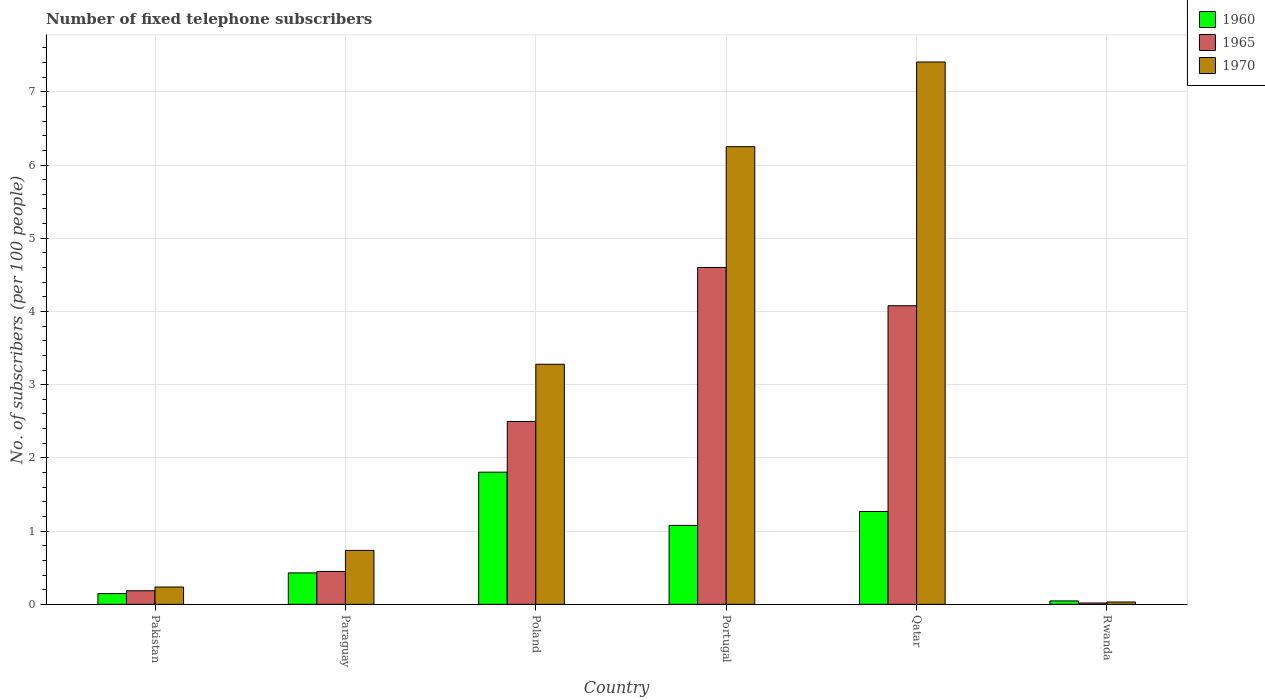Are the number of bars per tick equal to the number of legend labels?
Your response must be concise. Yes. Are the number of bars on each tick of the X-axis equal?
Your response must be concise. Yes. What is the label of the 5th group of bars from the left?
Your answer should be compact. Qatar. In how many cases, is the number of bars for a given country not equal to the number of legend labels?
Offer a terse response. 0. What is the number of fixed telephone subscribers in 1960 in Poland?
Ensure brevity in your answer.  1.81. Across all countries, what is the maximum number of fixed telephone subscribers in 1960?
Ensure brevity in your answer.  1.81. Across all countries, what is the minimum number of fixed telephone subscribers in 1965?
Offer a terse response. 0.02. In which country was the number of fixed telephone subscribers in 1960 minimum?
Provide a short and direct response. Rwanda. What is the total number of fixed telephone subscribers in 1960 in the graph?
Give a very brief answer. 4.77. What is the difference between the number of fixed telephone subscribers in 1970 in Paraguay and that in Portugal?
Provide a short and direct response. -5.51. What is the difference between the number of fixed telephone subscribers in 1965 in Poland and the number of fixed telephone subscribers in 1970 in Portugal?
Your answer should be very brief. -3.75. What is the average number of fixed telephone subscribers in 1960 per country?
Your answer should be very brief. 0.8. What is the difference between the number of fixed telephone subscribers of/in 1970 and number of fixed telephone subscribers of/in 1965 in Poland?
Keep it short and to the point. 0.78. In how many countries, is the number of fixed telephone subscribers in 1970 greater than 4.2?
Offer a terse response. 2. What is the ratio of the number of fixed telephone subscribers in 1970 in Paraguay to that in Qatar?
Your answer should be compact. 0.1. Is the number of fixed telephone subscribers in 1970 in Paraguay less than that in Portugal?
Give a very brief answer. Yes. What is the difference between the highest and the second highest number of fixed telephone subscribers in 1970?
Ensure brevity in your answer.  -2.97. What is the difference between the highest and the lowest number of fixed telephone subscribers in 1965?
Keep it short and to the point. 4.58. In how many countries, is the number of fixed telephone subscribers in 1960 greater than the average number of fixed telephone subscribers in 1960 taken over all countries?
Make the answer very short. 3. What does the 3rd bar from the left in Poland represents?
Make the answer very short. 1970. Are the values on the major ticks of Y-axis written in scientific E-notation?
Your answer should be very brief. No. Does the graph contain grids?
Your response must be concise. Yes. Where does the legend appear in the graph?
Offer a terse response. Top right. How many legend labels are there?
Your answer should be very brief. 3. How are the legend labels stacked?
Ensure brevity in your answer.  Vertical. What is the title of the graph?
Keep it short and to the point. Number of fixed telephone subscribers. Does "1979" appear as one of the legend labels in the graph?
Ensure brevity in your answer.  No. What is the label or title of the Y-axis?
Your answer should be very brief. No. of subscribers (per 100 people). What is the No. of subscribers (per 100 people) of 1960 in Pakistan?
Make the answer very short. 0.15. What is the No. of subscribers (per 100 people) in 1965 in Pakistan?
Offer a very short reply. 0.19. What is the No. of subscribers (per 100 people) of 1970 in Pakistan?
Offer a very short reply. 0.24. What is the No. of subscribers (per 100 people) of 1960 in Paraguay?
Provide a short and direct response. 0.43. What is the No. of subscribers (per 100 people) of 1965 in Paraguay?
Make the answer very short. 0.45. What is the No. of subscribers (per 100 people) in 1970 in Paraguay?
Offer a terse response. 0.74. What is the No. of subscribers (per 100 people) of 1960 in Poland?
Give a very brief answer. 1.81. What is the No. of subscribers (per 100 people) in 1965 in Poland?
Make the answer very short. 2.5. What is the No. of subscribers (per 100 people) in 1970 in Poland?
Keep it short and to the point. 3.28. What is the No. of subscribers (per 100 people) of 1960 in Portugal?
Your answer should be very brief. 1.08. What is the No. of subscribers (per 100 people) of 1965 in Portugal?
Give a very brief answer. 4.6. What is the No. of subscribers (per 100 people) in 1970 in Portugal?
Your answer should be very brief. 6.25. What is the No. of subscribers (per 100 people) of 1960 in Qatar?
Ensure brevity in your answer.  1.27. What is the No. of subscribers (per 100 people) of 1965 in Qatar?
Make the answer very short. 4.08. What is the No. of subscribers (per 100 people) in 1970 in Qatar?
Your answer should be compact. 7.41. What is the No. of subscribers (per 100 people) of 1960 in Rwanda?
Ensure brevity in your answer.  0.05. What is the No. of subscribers (per 100 people) in 1965 in Rwanda?
Provide a short and direct response. 0.02. What is the No. of subscribers (per 100 people) in 1970 in Rwanda?
Give a very brief answer. 0.03. Across all countries, what is the maximum No. of subscribers (per 100 people) of 1960?
Your answer should be compact. 1.81. Across all countries, what is the maximum No. of subscribers (per 100 people) of 1965?
Offer a terse response. 4.6. Across all countries, what is the maximum No. of subscribers (per 100 people) of 1970?
Ensure brevity in your answer.  7.41. Across all countries, what is the minimum No. of subscribers (per 100 people) of 1960?
Offer a terse response. 0.05. Across all countries, what is the minimum No. of subscribers (per 100 people) of 1965?
Ensure brevity in your answer.  0.02. Across all countries, what is the minimum No. of subscribers (per 100 people) of 1970?
Keep it short and to the point. 0.03. What is the total No. of subscribers (per 100 people) of 1960 in the graph?
Ensure brevity in your answer.  4.77. What is the total No. of subscribers (per 100 people) in 1965 in the graph?
Offer a terse response. 11.83. What is the total No. of subscribers (per 100 people) in 1970 in the graph?
Make the answer very short. 17.94. What is the difference between the No. of subscribers (per 100 people) of 1960 in Pakistan and that in Paraguay?
Your response must be concise. -0.28. What is the difference between the No. of subscribers (per 100 people) of 1965 in Pakistan and that in Paraguay?
Offer a very short reply. -0.26. What is the difference between the No. of subscribers (per 100 people) in 1970 in Pakistan and that in Paraguay?
Your answer should be compact. -0.5. What is the difference between the No. of subscribers (per 100 people) of 1960 in Pakistan and that in Poland?
Offer a terse response. -1.66. What is the difference between the No. of subscribers (per 100 people) in 1965 in Pakistan and that in Poland?
Give a very brief answer. -2.31. What is the difference between the No. of subscribers (per 100 people) of 1970 in Pakistan and that in Poland?
Your answer should be compact. -3.04. What is the difference between the No. of subscribers (per 100 people) of 1960 in Pakistan and that in Portugal?
Your response must be concise. -0.93. What is the difference between the No. of subscribers (per 100 people) of 1965 in Pakistan and that in Portugal?
Give a very brief answer. -4.42. What is the difference between the No. of subscribers (per 100 people) in 1970 in Pakistan and that in Portugal?
Ensure brevity in your answer.  -6.01. What is the difference between the No. of subscribers (per 100 people) in 1960 in Pakistan and that in Qatar?
Give a very brief answer. -1.12. What is the difference between the No. of subscribers (per 100 people) in 1965 in Pakistan and that in Qatar?
Your answer should be compact. -3.89. What is the difference between the No. of subscribers (per 100 people) in 1970 in Pakistan and that in Qatar?
Keep it short and to the point. -7.17. What is the difference between the No. of subscribers (per 100 people) of 1960 in Pakistan and that in Rwanda?
Ensure brevity in your answer.  0.1. What is the difference between the No. of subscribers (per 100 people) of 1965 in Pakistan and that in Rwanda?
Keep it short and to the point. 0.17. What is the difference between the No. of subscribers (per 100 people) in 1970 in Pakistan and that in Rwanda?
Provide a short and direct response. 0.2. What is the difference between the No. of subscribers (per 100 people) of 1960 in Paraguay and that in Poland?
Your answer should be compact. -1.38. What is the difference between the No. of subscribers (per 100 people) in 1965 in Paraguay and that in Poland?
Your answer should be very brief. -2.05. What is the difference between the No. of subscribers (per 100 people) of 1970 in Paraguay and that in Poland?
Your answer should be compact. -2.54. What is the difference between the No. of subscribers (per 100 people) of 1960 in Paraguay and that in Portugal?
Make the answer very short. -0.65. What is the difference between the No. of subscribers (per 100 people) of 1965 in Paraguay and that in Portugal?
Your answer should be very brief. -4.15. What is the difference between the No. of subscribers (per 100 people) of 1970 in Paraguay and that in Portugal?
Offer a terse response. -5.51. What is the difference between the No. of subscribers (per 100 people) of 1960 in Paraguay and that in Qatar?
Ensure brevity in your answer.  -0.84. What is the difference between the No. of subscribers (per 100 people) of 1965 in Paraguay and that in Qatar?
Give a very brief answer. -3.63. What is the difference between the No. of subscribers (per 100 people) in 1970 in Paraguay and that in Qatar?
Offer a very short reply. -6.67. What is the difference between the No. of subscribers (per 100 people) in 1960 in Paraguay and that in Rwanda?
Give a very brief answer. 0.38. What is the difference between the No. of subscribers (per 100 people) in 1965 in Paraguay and that in Rwanda?
Make the answer very short. 0.43. What is the difference between the No. of subscribers (per 100 people) of 1970 in Paraguay and that in Rwanda?
Ensure brevity in your answer.  0.7. What is the difference between the No. of subscribers (per 100 people) of 1960 in Poland and that in Portugal?
Provide a short and direct response. 0.73. What is the difference between the No. of subscribers (per 100 people) in 1965 in Poland and that in Portugal?
Your response must be concise. -2.1. What is the difference between the No. of subscribers (per 100 people) of 1970 in Poland and that in Portugal?
Your answer should be very brief. -2.97. What is the difference between the No. of subscribers (per 100 people) of 1960 in Poland and that in Qatar?
Ensure brevity in your answer.  0.54. What is the difference between the No. of subscribers (per 100 people) of 1965 in Poland and that in Qatar?
Your answer should be very brief. -1.58. What is the difference between the No. of subscribers (per 100 people) of 1970 in Poland and that in Qatar?
Offer a terse response. -4.13. What is the difference between the No. of subscribers (per 100 people) in 1960 in Poland and that in Rwanda?
Keep it short and to the point. 1.76. What is the difference between the No. of subscribers (per 100 people) of 1965 in Poland and that in Rwanda?
Ensure brevity in your answer.  2.48. What is the difference between the No. of subscribers (per 100 people) in 1970 in Poland and that in Rwanda?
Make the answer very short. 3.25. What is the difference between the No. of subscribers (per 100 people) in 1960 in Portugal and that in Qatar?
Provide a short and direct response. -0.19. What is the difference between the No. of subscribers (per 100 people) in 1965 in Portugal and that in Qatar?
Your answer should be compact. 0.52. What is the difference between the No. of subscribers (per 100 people) in 1970 in Portugal and that in Qatar?
Keep it short and to the point. -1.16. What is the difference between the No. of subscribers (per 100 people) in 1960 in Portugal and that in Rwanda?
Ensure brevity in your answer.  1.03. What is the difference between the No. of subscribers (per 100 people) of 1965 in Portugal and that in Rwanda?
Provide a succinct answer. 4.58. What is the difference between the No. of subscribers (per 100 people) of 1970 in Portugal and that in Rwanda?
Your answer should be compact. 6.22. What is the difference between the No. of subscribers (per 100 people) of 1960 in Qatar and that in Rwanda?
Your answer should be compact. 1.22. What is the difference between the No. of subscribers (per 100 people) of 1965 in Qatar and that in Rwanda?
Your answer should be compact. 4.06. What is the difference between the No. of subscribers (per 100 people) of 1970 in Qatar and that in Rwanda?
Offer a terse response. 7.38. What is the difference between the No. of subscribers (per 100 people) in 1960 in Pakistan and the No. of subscribers (per 100 people) in 1965 in Paraguay?
Offer a very short reply. -0.3. What is the difference between the No. of subscribers (per 100 people) in 1960 in Pakistan and the No. of subscribers (per 100 people) in 1970 in Paraguay?
Provide a short and direct response. -0.59. What is the difference between the No. of subscribers (per 100 people) in 1965 in Pakistan and the No. of subscribers (per 100 people) in 1970 in Paraguay?
Ensure brevity in your answer.  -0.55. What is the difference between the No. of subscribers (per 100 people) of 1960 in Pakistan and the No. of subscribers (per 100 people) of 1965 in Poland?
Offer a very short reply. -2.35. What is the difference between the No. of subscribers (per 100 people) of 1960 in Pakistan and the No. of subscribers (per 100 people) of 1970 in Poland?
Provide a succinct answer. -3.13. What is the difference between the No. of subscribers (per 100 people) of 1965 in Pakistan and the No. of subscribers (per 100 people) of 1970 in Poland?
Give a very brief answer. -3.09. What is the difference between the No. of subscribers (per 100 people) of 1960 in Pakistan and the No. of subscribers (per 100 people) of 1965 in Portugal?
Provide a short and direct response. -4.45. What is the difference between the No. of subscribers (per 100 people) in 1960 in Pakistan and the No. of subscribers (per 100 people) in 1970 in Portugal?
Offer a very short reply. -6.1. What is the difference between the No. of subscribers (per 100 people) in 1965 in Pakistan and the No. of subscribers (per 100 people) in 1970 in Portugal?
Make the answer very short. -6.07. What is the difference between the No. of subscribers (per 100 people) of 1960 in Pakistan and the No. of subscribers (per 100 people) of 1965 in Qatar?
Your answer should be compact. -3.93. What is the difference between the No. of subscribers (per 100 people) in 1960 in Pakistan and the No. of subscribers (per 100 people) in 1970 in Qatar?
Provide a short and direct response. -7.26. What is the difference between the No. of subscribers (per 100 people) of 1965 in Pakistan and the No. of subscribers (per 100 people) of 1970 in Qatar?
Provide a short and direct response. -7.22. What is the difference between the No. of subscribers (per 100 people) of 1960 in Pakistan and the No. of subscribers (per 100 people) of 1965 in Rwanda?
Your answer should be very brief. 0.13. What is the difference between the No. of subscribers (per 100 people) of 1960 in Pakistan and the No. of subscribers (per 100 people) of 1970 in Rwanda?
Offer a terse response. 0.11. What is the difference between the No. of subscribers (per 100 people) in 1965 in Pakistan and the No. of subscribers (per 100 people) in 1970 in Rwanda?
Your answer should be very brief. 0.15. What is the difference between the No. of subscribers (per 100 people) of 1960 in Paraguay and the No. of subscribers (per 100 people) of 1965 in Poland?
Your answer should be compact. -2.07. What is the difference between the No. of subscribers (per 100 people) in 1960 in Paraguay and the No. of subscribers (per 100 people) in 1970 in Poland?
Give a very brief answer. -2.85. What is the difference between the No. of subscribers (per 100 people) of 1965 in Paraguay and the No. of subscribers (per 100 people) of 1970 in Poland?
Provide a succinct answer. -2.83. What is the difference between the No. of subscribers (per 100 people) in 1960 in Paraguay and the No. of subscribers (per 100 people) in 1965 in Portugal?
Keep it short and to the point. -4.17. What is the difference between the No. of subscribers (per 100 people) in 1960 in Paraguay and the No. of subscribers (per 100 people) in 1970 in Portugal?
Your response must be concise. -5.82. What is the difference between the No. of subscribers (per 100 people) in 1965 in Paraguay and the No. of subscribers (per 100 people) in 1970 in Portugal?
Offer a terse response. -5.8. What is the difference between the No. of subscribers (per 100 people) in 1960 in Paraguay and the No. of subscribers (per 100 people) in 1965 in Qatar?
Ensure brevity in your answer.  -3.65. What is the difference between the No. of subscribers (per 100 people) of 1960 in Paraguay and the No. of subscribers (per 100 people) of 1970 in Qatar?
Ensure brevity in your answer.  -6.98. What is the difference between the No. of subscribers (per 100 people) in 1965 in Paraguay and the No. of subscribers (per 100 people) in 1970 in Qatar?
Offer a very short reply. -6.96. What is the difference between the No. of subscribers (per 100 people) in 1960 in Paraguay and the No. of subscribers (per 100 people) in 1965 in Rwanda?
Provide a succinct answer. 0.41. What is the difference between the No. of subscribers (per 100 people) of 1960 in Paraguay and the No. of subscribers (per 100 people) of 1970 in Rwanda?
Ensure brevity in your answer.  0.4. What is the difference between the No. of subscribers (per 100 people) of 1965 in Paraguay and the No. of subscribers (per 100 people) of 1970 in Rwanda?
Your response must be concise. 0.42. What is the difference between the No. of subscribers (per 100 people) in 1960 in Poland and the No. of subscribers (per 100 people) in 1965 in Portugal?
Provide a succinct answer. -2.8. What is the difference between the No. of subscribers (per 100 people) in 1960 in Poland and the No. of subscribers (per 100 people) in 1970 in Portugal?
Make the answer very short. -4.45. What is the difference between the No. of subscribers (per 100 people) of 1965 in Poland and the No. of subscribers (per 100 people) of 1970 in Portugal?
Your answer should be very brief. -3.75. What is the difference between the No. of subscribers (per 100 people) in 1960 in Poland and the No. of subscribers (per 100 people) in 1965 in Qatar?
Keep it short and to the point. -2.27. What is the difference between the No. of subscribers (per 100 people) in 1960 in Poland and the No. of subscribers (per 100 people) in 1970 in Qatar?
Provide a succinct answer. -5.6. What is the difference between the No. of subscribers (per 100 people) of 1965 in Poland and the No. of subscribers (per 100 people) of 1970 in Qatar?
Provide a short and direct response. -4.91. What is the difference between the No. of subscribers (per 100 people) of 1960 in Poland and the No. of subscribers (per 100 people) of 1965 in Rwanda?
Ensure brevity in your answer.  1.79. What is the difference between the No. of subscribers (per 100 people) of 1960 in Poland and the No. of subscribers (per 100 people) of 1970 in Rwanda?
Offer a very short reply. 1.77. What is the difference between the No. of subscribers (per 100 people) of 1965 in Poland and the No. of subscribers (per 100 people) of 1970 in Rwanda?
Ensure brevity in your answer.  2.47. What is the difference between the No. of subscribers (per 100 people) in 1960 in Portugal and the No. of subscribers (per 100 people) in 1965 in Qatar?
Offer a terse response. -3. What is the difference between the No. of subscribers (per 100 people) in 1960 in Portugal and the No. of subscribers (per 100 people) in 1970 in Qatar?
Give a very brief answer. -6.33. What is the difference between the No. of subscribers (per 100 people) of 1965 in Portugal and the No. of subscribers (per 100 people) of 1970 in Qatar?
Your answer should be compact. -2.81. What is the difference between the No. of subscribers (per 100 people) in 1960 in Portugal and the No. of subscribers (per 100 people) in 1965 in Rwanda?
Your answer should be very brief. 1.06. What is the difference between the No. of subscribers (per 100 people) of 1960 in Portugal and the No. of subscribers (per 100 people) of 1970 in Rwanda?
Give a very brief answer. 1.05. What is the difference between the No. of subscribers (per 100 people) of 1965 in Portugal and the No. of subscribers (per 100 people) of 1970 in Rwanda?
Keep it short and to the point. 4.57. What is the difference between the No. of subscribers (per 100 people) in 1960 in Qatar and the No. of subscribers (per 100 people) in 1965 in Rwanda?
Your answer should be very brief. 1.25. What is the difference between the No. of subscribers (per 100 people) in 1960 in Qatar and the No. of subscribers (per 100 people) in 1970 in Rwanda?
Make the answer very short. 1.24. What is the difference between the No. of subscribers (per 100 people) in 1965 in Qatar and the No. of subscribers (per 100 people) in 1970 in Rwanda?
Give a very brief answer. 4.05. What is the average No. of subscribers (per 100 people) in 1960 per country?
Give a very brief answer. 0.8. What is the average No. of subscribers (per 100 people) of 1965 per country?
Your answer should be compact. 1.97. What is the average No. of subscribers (per 100 people) of 1970 per country?
Your response must be concise. 2.99. What is the difference between the No. of subscribers (per 100 people) in 1960 and No. of subscribers (per 100 people) in 1965 in Pakistan?
Your answer should be very brief. -0.04. What is the difference between the No. of subscribers (per 100 people) of 1960 and No. of subscribers (per 100 people) of 1970 in Pakistan?
Your answer should be compact. -0.09. What is the difference between the No. of subscribers (per 100 people) in 1965 and No. of subscribers (per 100 people) in 1970 in Pakistan?
Your response must be concise. -0.05. What is the difference between the No. of subscribers (per 100 people) in 1960 and No. of subscribers (per 100 people) in 1965 in Paraguay?
Your answer should be very brief. -0.02. What is the difference between the No. of subscribers (per 100 people) of 1960 and No. of subscribers (per 100 people) of 1970 in Paraguay?
Give a very brief answer. -0.31. What is the difference between the No. of subscribers (per 100 people) in 1965 and No. of subscribers (per 100 people) in 1970 in Paraguay?
Your answer should be compact. -0.29. What is the difference between the No. of subscribers (per 100 people) of 1960 and No. of subscribers (per 100 people) of 1965 in Poland?
Provide a succinct answer. -0.69. What is the difference between the No. of subscribers (per 100 people) in 1960 and No. of subscribers (per 100 people) in 1970 in Poland?
Ensure brevity in your answer.  -1.47. What is the difference between the No. of subscribers (per 100 people) in 1965 and No. of subscribers (per 100 people) in 1970 in Poland?
Give a very brief answer. -0.78. What is the difference between the No. of subscribers (per 100 people) of 1960 and No. of subscribers (per 100 people) of 1965 in Portugal?
Provide a succinct answer. -3.52. What is the difference between the No. of subscribers (per 100 people) in 1960 and No. of subscribers (per 100 people) in 1970 in Portugal?
Provide a short and direct response. -5.17. What is the difference between the No. of subscribers (per 100 people) in 1965 and No. of subscribers (per 100 people) in 1970 in Portugal?
Provide a short and direct response. -1.65. What is the difference between the No. of subscribers (per 100 people) in 1960 and No. of subscribers (per 100 people) in 1965 in Qatar?
Provide a short and direct response. -2.81. What is the difference between the No. of subscribers (per 100 people) in 1960 and No. of subscribers (per 100 people) in 1970 in Qatar?
Your answer should be very brief. -6.14. What is the difference between the No. of subscribers (per 100 people) in 1965 and No. of subscribers (per 100 people) in 1970 in Qatar?
Keep it short and to the point. -3.33. What is the difference between the No. of subscribers (per 100 people) in 1960 and No. of subscribers (per 100 people) in 1965 in Rwanda?
Provide a short and direct response. 0.03. What is the difference between the No. of subscribers (per 100 people) in 1960 and No. of subscribers (per 100 people) in 1970 in Rwanda?
Make the answer very short. 0.01. What is the difference between the No. of subscribers (per 100 people) in 1965 and No. of subscribers (per 100 people) in 1970 in Rwanda?
Make the answer very short. -0.01. What is the ratio of the No. of subscribers (per 100 people) in 1960 in Pakistan to that in Paraguay?
Your response must be concise. 0.34. What is the ratio of the No. of subscribers (per 100 people) in 1965 in Pakistan to that in Paraguay?
Offer a very short reply. 0.41. What is the ratio of the No. of subscribers (per 100 people) in 1970 in Pakistan to that in Paraguay?
Your answer should be very brief. 0.32. What is the ratio of the No. of subscribers (per 100 people) in 1960 in Pakistan to that in Poland?
Give a very brief answer. 0.08. What is the ratio of the No. of subscribers (per 100 people) of 1965 in Pakistan to that in Poland?
Offer a terse response. 0.07. What is the ratio of the No. of subscribers (per 100 people) of 1970 in Pakistan to that in Poland?
Ensure brevity in your answer.  0.07. What is the ratio of the No. of subscribers (per 100 people) of 1960 in Pakistan to that in Portugal?
Your answer should be compact. 0.14. What is the ratio of the No. of subscribers (per 100 people) in 1965 in Pakistan to that in Portugal?
Provide a succinct answer. 0.04. What is the ratio of the No. of subscribers (per 100 people) of 1970 in Pakistan to that in Portugal?
Your response must be concise. 0.04. What is the ratio of the No. of subscribers (per 100 people) in 1960 in Pakistan to that in Qatar?
Provide a succinct answer. 0.12. What is the ratio of the No. of subscribers (per 100 people) in 1965 in Pakistan to that in Qatar?
Offer a very short reply. 0.05. What is the ratio of the No. of subscribers (per 100 people) in 1970 in Pakistan to that in Qatar?
Your answer should be very brief. 0.03. What is the ratio of the No. of subscribers (per 100 people) in 1960 in Pakistan to that in Rwanda?
Offer a terse response. 3.15. What is the ratio of the No. of subscribers (per 100 people) in 1965 in Pakistan to that in Rwanda?
Offer a terse response. 10. What is the ratio of the No. of subscribers (per 100 people) of 1970 in Pakistan to that in Rwanda?
Your response must be concise. 7.4. What is the ratio of the No. of subscribers (per 100 people) in 1960 in Paraguay to that in Poland?
Give a very brief answer. 0.24. What is the ratio of the No. of subscribers (per 100 people) in 1965 in Paraguay to that in Poland?
Offer a terse response. 0.18. What is the ratio of the No. of subscribers (per 100 people) in 1970 in Paraguay to that in Poland?
Give a very brief answer. 0.22. What is the ratio of the No. of subscribers (per 100 people) in 1960 in Paraguay to that in Portugal?
Offer a terse response. 0.4. What is the ratio of the No. of subscribers (per 100 people) of 1965 in Paraguay to that in Portugal?
Your answer should be compact. 0.1. What is the ratio of the No. of subscribers (per 100 people) of 1970 in Paraguay to that in Portugal?
Offer a terse response. 0.12. What is the ratio of the No. of subscribers (per 100 people) in 1960 in Paraguay to that in Qatar?
Your answer should be very brief. 0.34. What is the ratio of the No. of subscribers (per 100 people) in 1965 in Paraguay to that in Qatar?
Make the answer very short. 0.11. What is the ratio of the No. of subscribers (per 100 people) of 1970 in Paraguay to that in Qatar?
Ensure brevity in your answer.  0.1. What is the ratio of the No. of subscribers (per 100 people) of 1960 in Paraguay to that in Rwanda?
Make the answer very short. 9.22. What is the ratio of the No. of subscribers (per 100 people) of 1965 in Paraguay to that in Rwanda?
Ensure brevity in your answer.  24.22. What is the ratio of the No. of subscribers (per 100 people) of 1970 in Paraguay to that in Rwanda?
Your answer should be very brief. 23.04. What is the ratio of the No. of subscribers (per 100 people) in 1960 in Poland to that in Portugal?
Provide a short and direct response. 1.67. What is the ratio of the No. of subscribers (per 100 people) in 1965 in Poland to that in Portugal?
Ensure brevity in your answer.  0.54. What is the ratio of the No. of subscribers (per 100 people) in 1970 in Poland to that in Portugal?
Your answer should be compact. 0.52. What is the ratio of the No. of subscribers (per 100 people) of 1960 in Poland to that in Qatar?
Make the answer very short. 1.42. What is the ratio of the No. of subscribers (per 100 people) in 1965 in Poland to that in Qatar?
Your answer should be compact. 0.61. What is the ratio of the No. of subscribers (per 100 people) in 1970 in Poland to that in Qatar?
Keep it short and to the point. 0.44. What is the ratio of the No. of subscribers (per 100 people) in 1960 in Poland to that in Rwanda?
Your answer should be compact. 38.77. What is the ratio of the No. of subscribers (per 100 people) of 1965 in Poland to that in Rwanda?
Your answer should be compact. 134.57. What is the ratio of the No. of subscribers (per 100 people) of 1970 in Poland to that in Rwanda?
Ensure brevity in your answer.  102.59. What is the ratio of the No. of subscribers (per 100 people) of 1960 in Portugal to that in Qatar?
Provide a succinct answer. 0.85. What is the ratio of the No. of subscribers (per 100 people) in 1965 in Portugal to that in Qatar?
Make the answer very short. 1.13. What is the ratio of the No. of subscribers (per 100 people) of 1970 in Portugal to that in Qatar?
Ensure brevity in your answer.  0.84. What is the ratio of the No. of subscribers (per 100 people) in 1960 in Portugal to that in Rwanda?
Your response must be concise. 23.15. What is the ratio of the No. of subscribers (per 100 people) in 1965 in Portugal to that in Rwanda?
Keep it short and to the point. 247.93. What is the ratio of the No. of subscribers (per 100 people) of 1970 in Portugal to that in Rwanda?
Give a very brief answer. 195.59. What is the ratio of the No. of subscribers (per 100 people) in 1960 in Qatar to that in Rwanda?
Offer a very short reply. 27.23. What is the ratio of the No. of subscribers (per 100 people) of 1965 in Qatar to that in Rwanda?
Ensure brevity in your answer.  219.77. What is the ratio of the No. of subscribers (per 100 people) of 1970 in Qatar to that in Rwanda?
Provide a succinct answer. 231.78. What is the difference between the highest and the second highest No. of subscribers (per 100 people) in 1960?
Offer a terse response. 0.54. What is the difference between the highest and the second highest No. of subscribers (per 100 people) in 1965?
Offer a very short reply. 0.52. What is the difference between the highest and the second highest No. of subscribers (per 100 people) of 1970?
Offer a very short reply. 1.16. What is the difference between the highest and the lowest No. of subscribers (per 100 people) of 1960?
Offer a terse response. 1.76. What is the difference between the highest and the lowest No. of subscribers (per 100 people) in 1965?
Your answer should be very brief. 4.58. What is the difference between the highest and the lowest No. of subscribers (per 100 people) in 1970?
Your answer should be very brief. 7.38. 